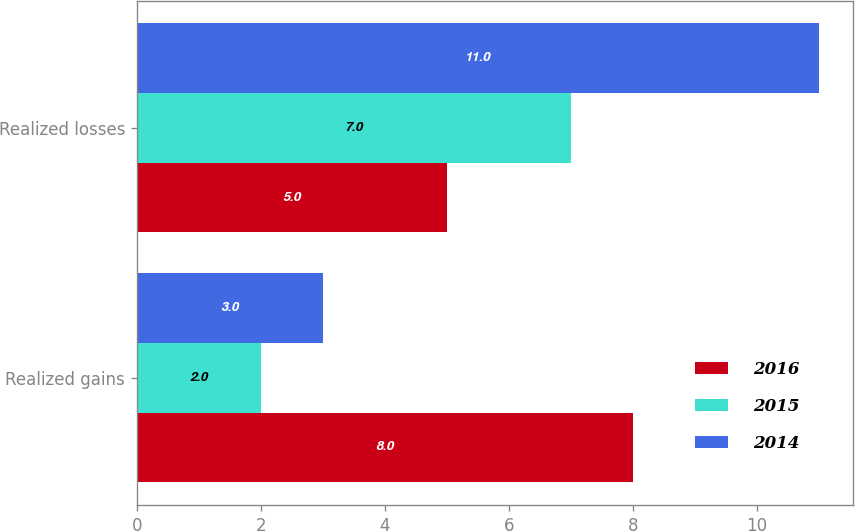Convert chart. <chart><loc_0><loc_0><loc_500><loc_500><stacked_bar_chart><ecel><fcel>Realized gains<fcel>Realized losses<nl><fcel>2016<fcel>8<fcel>5<nl><fcel>2015<fcel>2<fcel>7<nl><fcel>2014<fcel>3<fcel>11<nl></chart> 